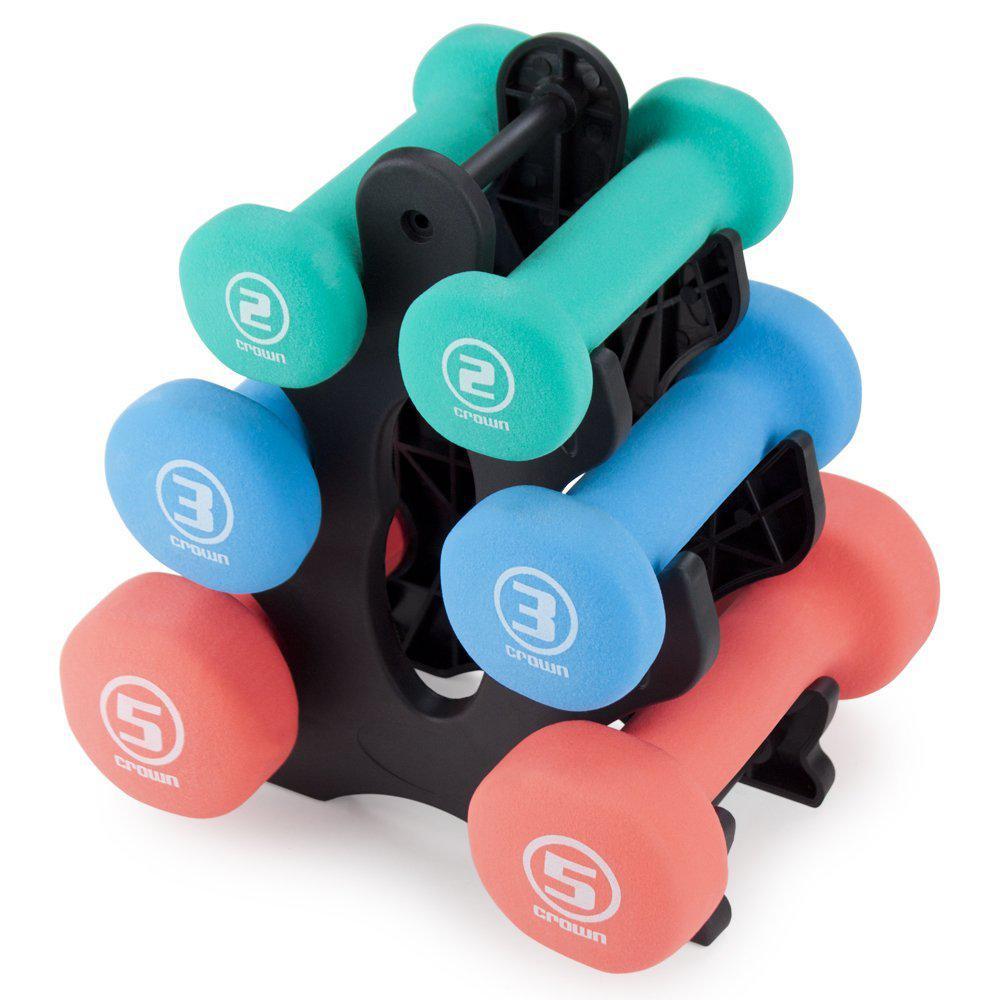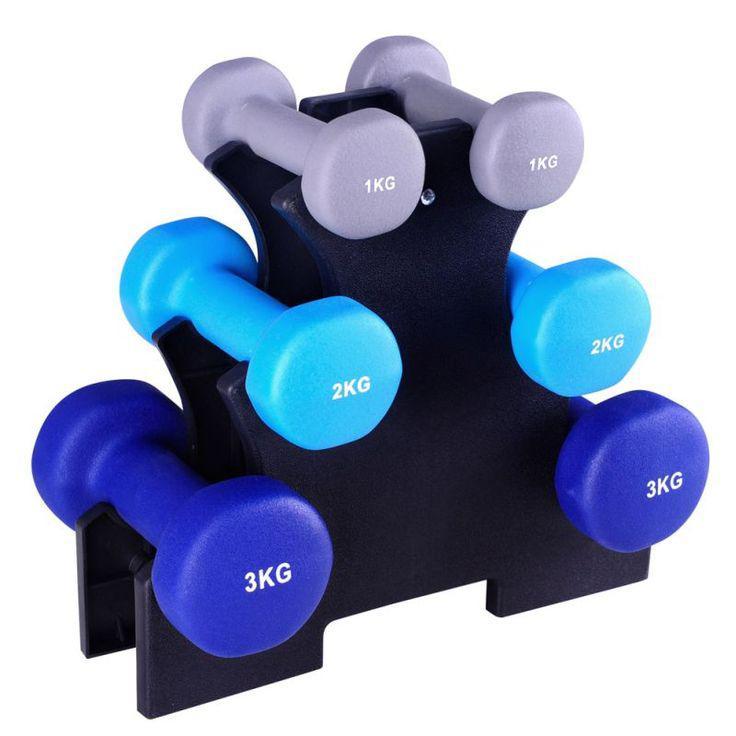The first image is the image on the left, the second image is the image on the right. For the images displayed, is the sentence "In each image, three pairs of dumbbells, each a different color, at stacked on a triangular shaped rack with a pink pair in the uppermost position." factually correct? Answer yes or no. No. 